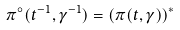<formula> <loc_0><loc_0><loc_500><loc_500>\pi ^ { \circ } ( t ^ { - 1 } , \gamma ^ { - 1 } ) = ( \pi ( t , \gamma ) ) ^ { * }</formula> 